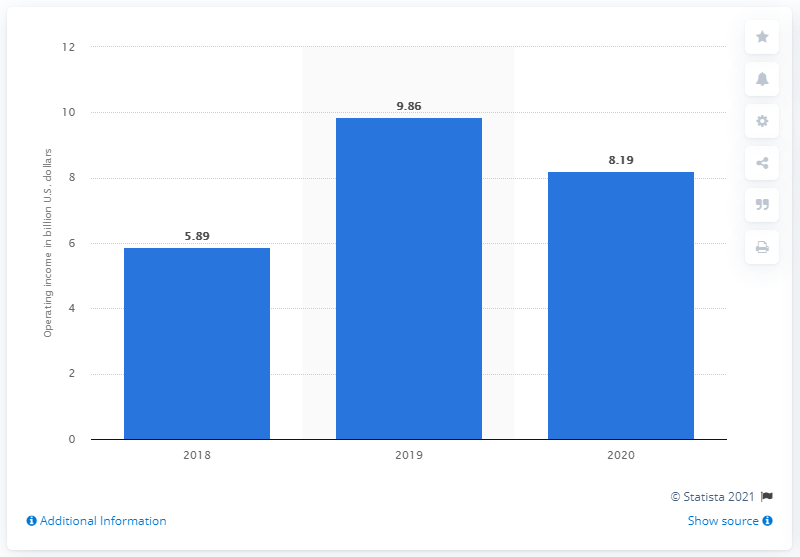Mention a couple of crucial points in this snapshot. In the year 2020, AT&T reported the income of WarnerMedia. In 2020, WarnerMedia reported global operating income of approximately 8.19 billion dollars. 